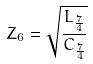Convert formula to latex. <formula><loc_0><loc_0><loc_500><loc_500>Z _ { 6 } = \sqrt { \frac { L _ { \frac { 7 } { 4 } } } { C _ { \frac { 7 } { 4 } } } }</formula> 